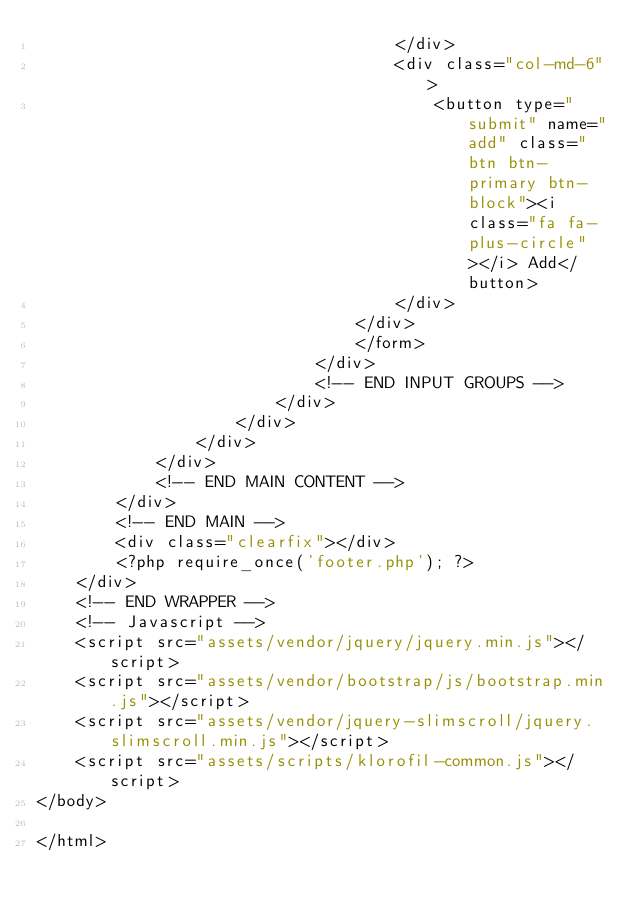Convert code to text. <code><loc_0><loc_0><loc_500><loc_500><_PHP_>									</div>
									<div class="col-md-6">
										<button type="submit" name="add" class="btn btn-primary btn-block"><i class="fa fa-plus-circle"></i> Add</button>
									</div>
								</div>
								</form>
							</div>
							<!-- END INPUT GROUPS -->
						</div>
					</div>
				</div>
			</div>
			<!-- END MAIN CONTENT -->
		</div>
		<!-- END MAIN -->
		<div class="clearfix"></div>
		<?php require_once('footer.php'); ?>
	</div>
	<!-- END WRAPPER -->
	<!-- Javascript -->
	<script src="assets/vendor/jquery/jquery.min.js"></script>
	<script src="assets/vendor/bootstrap/js/bootstrap.min.js"></script>
	<script src="assets/vendor/jquery-slimscroll/jquery.slimscroll.min.js"></script>
	<script src="assets/scripts/klorofil-common.js"></script>
</body>

</html>
</code> 